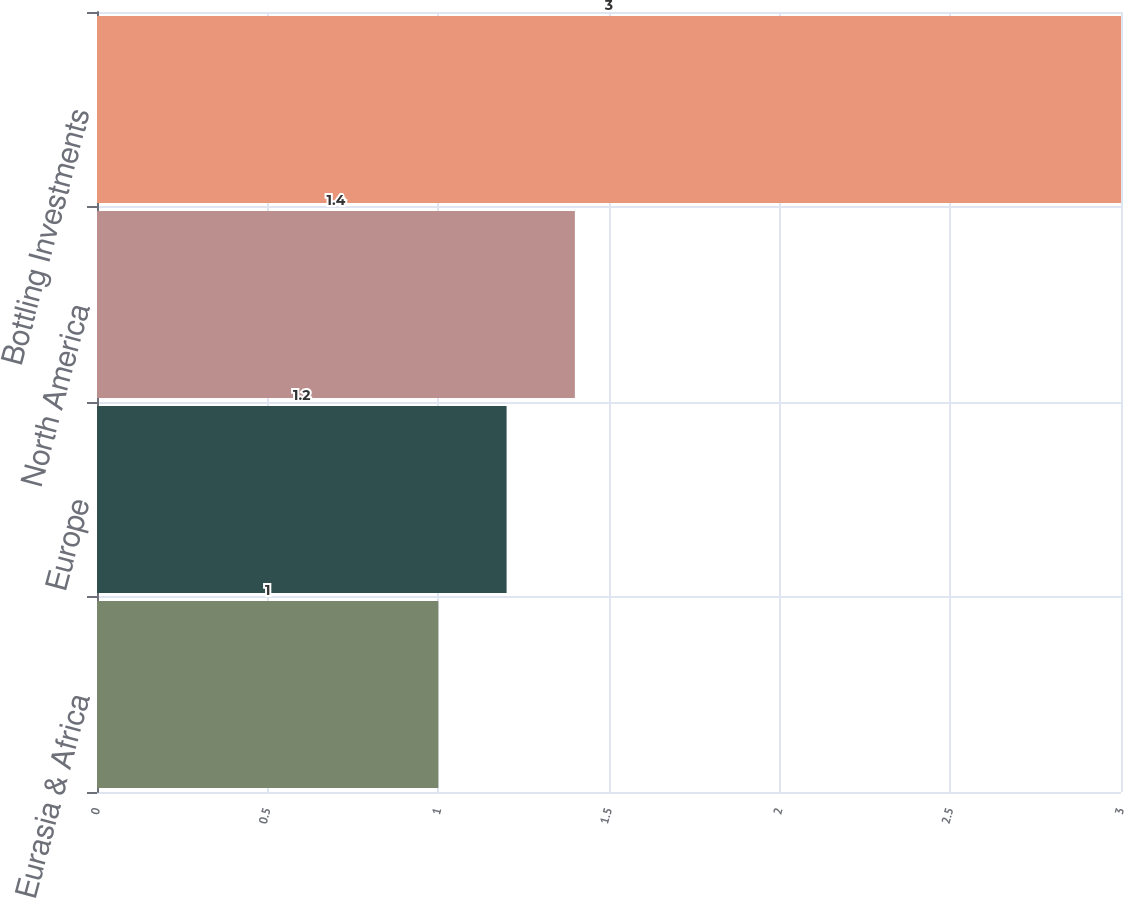Convert chart to OTSL. <chart><loc_0><loc_0><loc_500><loc_500><bar_chart><fcel>Eurasia & Africa<fcel>Europe<fcel>North America<fcel>Bottling Investments<nl><fcel>1<fcel>1.2<fcel>1.4<fcel>3<nl></chart> 